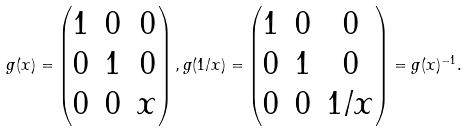<formula> <loc_0><loc_0><loc_500><loc_500>g ( x ) = \begin{pmatrix} 1 & 0 & 0 \\ 0 & 1 & 0 \\ 0 & 0 & x \end{pmatrix} , g ( 1 / x ) = \begin{pmatrix} 1 & 0 & 0 \\ 0 & 1 & 0 \\ 0 & 0 & 1 / x \end{pmatrix} = g ( x ) ^ { - 1 } .</formula> 